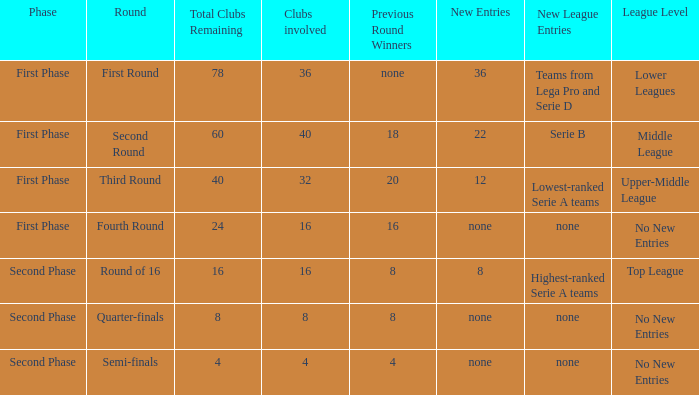After observing 8 new entries in this round, what is the total number of clubs left? 1.0. 